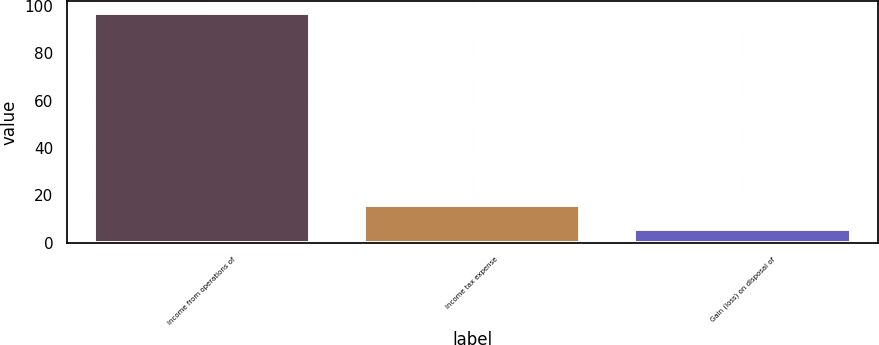<chart> <loc_0><loc_0><loc_500><loc_500><bar_chart><fcel>Income from operations of<fcel>Income tax expense<fcel>Gain (loss) on disposal of<nl><fcel>97<fcel>15.8<fcel>6<nl></chart> 